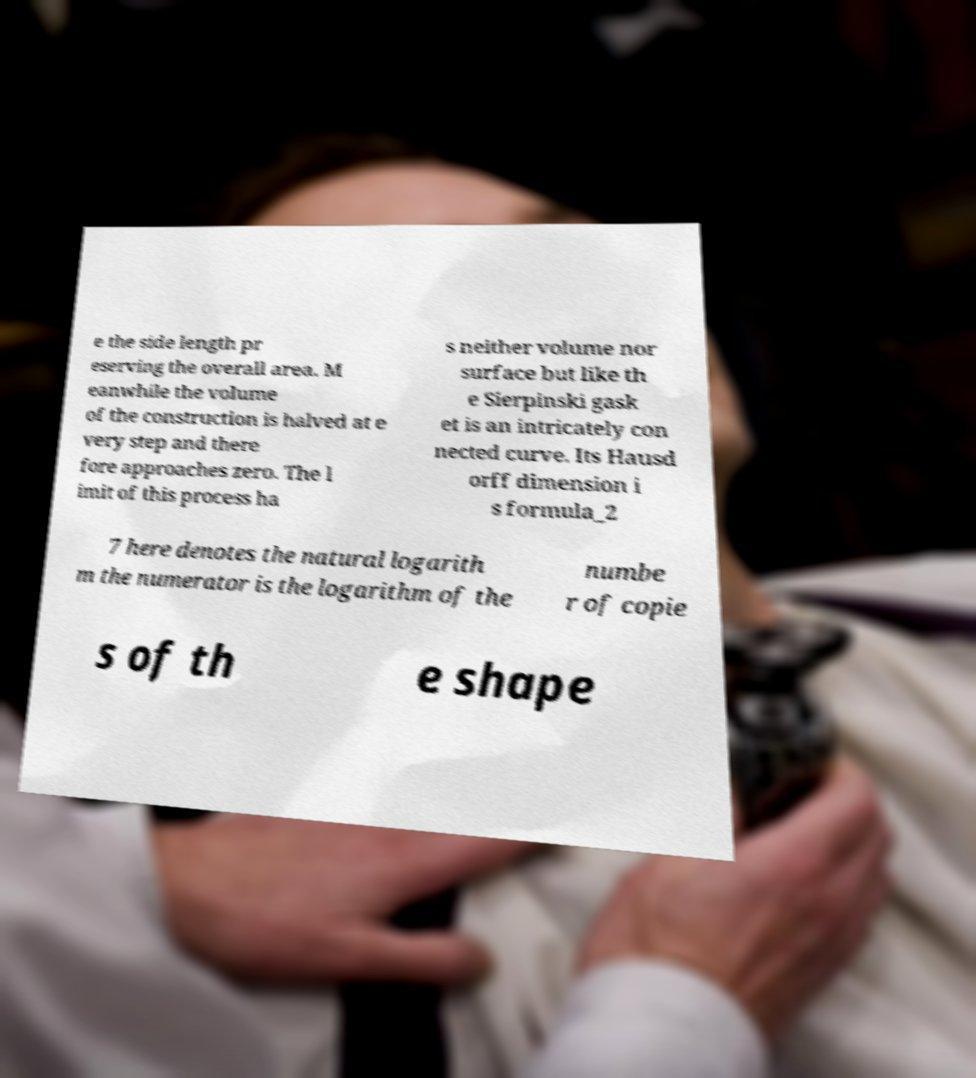What messages or text are displayed in this image? I need them in a readable, typed format. e the side length pr eserving the overall area. M eanwhile the volume of the construction is halved at e very step and there fore approaches zero. The l imit of this process ha s neither volume nor surface but like th e Sierpinski gask et is an intricately con nected curve. Its Hausd orff dimension i s formula_2 7 here denotes the natural logarith m the numerator is the logarithm of the numbe r of copie s of th e shape 